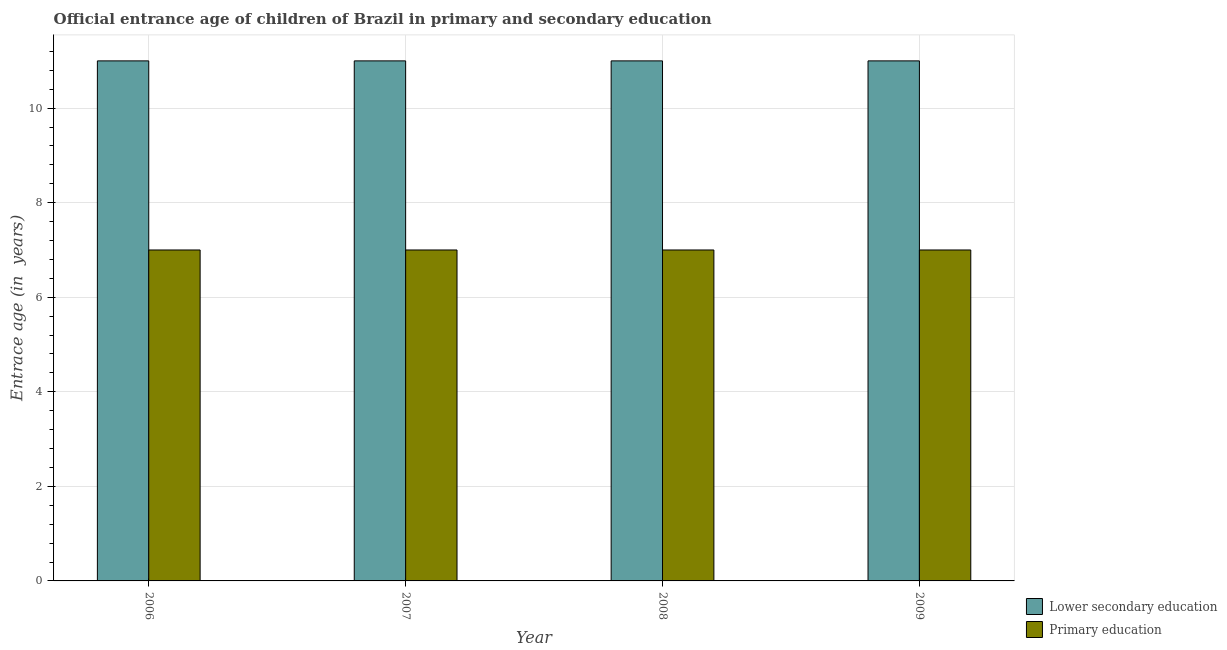How many different coloured bars are there?
Your answer should be very brief. 2. How many groups of bars are there?
Keep it short and to the point. 4. Are the number of bars per tick equal to the number of legend labels?
Keep it short and to the point. Yes. How many bars are there on the 4th tick from the left?
Ensure brevity in your answer.  2. In how many cases, is the number of bars for a given year not equal to the number of legend labels?
Your answer should be compact. 0. What is the entrance age of chiildren in primary education in 2008?
Your answer should be very brief. 7. Across all years, what is the maximum entrance age of chiildren in primary education?
Your response must be concise. 7. Across all years, what is the minimum entrance age of children in lower secondary education?
Your answer should be very brief. 11. What is the total entrance age of chiildren in primary education in the graph?
Offer a terse response. 28. What is the difference between the entrance age of children in lower secondary education in 2008 and the entrance age of chiildren in primary education in 2007?
Provide a short and direct response. 0. What is the average entrance age of children in lower secondary education per year?
Provide a succinct answer. 11. In the year 2007, what is the difference between the entrance age of children in lower secondary education and entrance age of chiildren in primary education?
Offer a terse response. 0. Is the entrance age of children in lower secondary education in 2007 less than that in 2009?
Make the answer very short. No. Is the difference between the entrance age of chiildren in primary education in 2006 and 2008 greater than the difference between the entrance age of children in lower secondary education in 2006 and 2008?
Give a very brief answer. No. What is the difference between the highest and the second highest entrance age of children in lower secondary education?
Provide a short and direct response. 0. Is the sum of the entrance age of children in lower secondary education in 2007 and 2008 greater than the maximum entrance age of chiildren in primary education across all years?
Make the answer very short. Yes. How many bars are there?
Give a very brief answer. 8. Are all the bars in the graph horizontal?
Offer a very short reply. No. What is the difference between two consecutive major ticks on the Y-axis?
Ensure brevity in your answer.  2. Are the values on the major ticks of Y-axis written in scientific E-notation?
Offer a terse response. No. Does the graph contain any zero values?
Your answer should be compact. No. Does the graph contain grids?
Ensure brevity in your answer.  Yes. Where does the legend appear in the graph?
Your answer should be compact. Bottom right. How are the legend labels stacked?
Offer a terse response. Vertical. What is the title of the graph?
Offer a terse response. Official entrance age of children of Brazil in primary and secondary education. Does "Electricity" appear as one of the legend labels in the graph?
Keep it short and to the point. No. What is the label or title of the X-axis?
Offer a terse response. Year. What is the label or title of the Y-axis?
Your response must be concise. Entrace age (in  years). What is the Entrace age (in  years) in Primary education in 2006?
Offer a very short reply. 7. What is the Entrace age (in  years) of Primary education in 2008?
Offer a very short reply. 7. What is the Entrace age (in  years) in Lower secondary education in 2009?
Provide a short and direct response. 11. Across all years, what is the maximum Entrace age (in  years) of Lower secondary education?
Make the answer very short. 11. Across all years, what is the minimum Entrace age (in  years) in Lower secondary education?
Provide a short and direct response. 11. What is the total Entrace age (in  years) of Lower secondary education in the graph?
Provide a succinct answer. 44. What is the total Entrace age (in  years) in Primary education in the graph?
Offer a very short reply. 28. What is the difference between the Entrace age (in  years) in Primary education in 2006 and that in 2007?
Give a very brief answer. 0. What is the difference between the Entrace age (in  years) of Lower secondary education in 2006 and that in 2008?
Keep it short and to the point. 0. What is the difference between the Entrace age (in  years) of Primary education in 2006 and that in 2008?
Provide a short and direct response. 0. What is the difference between the Entrace age (in  years) of Lower secondary education in 2006 and that in 2009?
Ensure brevity in your answer.  0. What is the difference between the Entrace age (in  years) in Lower secondary education in 2007 and that in 2008?
Provide a succinct answer. 0. What is the difference between the Entrace age (in  years) in Lower secondary education in 2007 and that in 2009?
Ensure brevity in your answer.  0. What is the difference between the Entrace age (in  years) in Lower secondary education in 2008 and that in 2009?
Ensure brevity in your answer.  0. What is the difference between the Entrace age (in  years) in Primary education in 2008 and that in 2009?
Provide a succinct answer. 0. What is the difference between the Entrace age (in  years) of Lower secondary education in 2006 and the Entrace age (in  years) of Primary education in 2008?
Provide a succinct answer. 4. What is the difference between the Entrace age (in  years) in Lower secondary education in 2007 and the Entrace age (in  years) in Primary education in 2008?
Your answer should be compact. 4. In the year 2006, what is the difference between the Entrace age (in  years) in Lower secondary education and Entrace age (in  years) in Primary education?
Give a very brief answer. 4. In the year 2008, what is the difference between the Entrace age (in  years) of Lower secondary education and Entrace age (in  years) of Primary education?
Give a very brief answer. 4. What is the ratio of the Entrace age (in  years) in Lower secondary education in 2006 to that in 2007?
Your answer should be very brief. 1. What is the ratio of the Entrace age (in  years) in Primary education in 2006 to that in 2007?
Your answer should be compact. 1. What is the ratio of the Entrace age (in  years) in Lower secondary education in 2006 to that in 2008?
Provide a short and direct response. 1. What is the ratio of the Entrace age (in  years) in Primary education in 2006 to that in 2008?
Make the answer very short. 1. What is the ratio of the Entrace age (in  years) in Lower secondary education in 2007 to that in 2008?
Your answer should be very brief. 1. What is the ratio of the Entrace age (in  years) in Primary education in 2007 to that in 2008?
Your response must be concise. 1. What is the ratio of the Entrace age (in  years) of Lower secondary education in 2007 to that in 2009?
Your answer should be compact. 1. What is the difference between the highest and the second highest Entrace age (in  years) of Lower secondary education?
Make the answer very short. 0. What is the difference between the highest and the second highest Entrace age (in  years) of Primary education?
Your answer should be very brief. 0. What is the difference between the highest and the lowest Entrace age (in  years) in Lower secondary education?
Your response must be concise. 0. 